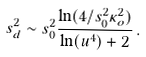<formula> <loc_0><loc_0><loc_500><loc_500>s _ { d } ^ { 2 } \sim s _ { 0 } ^ { 2 } \frac { \ln ( 4 / s _ { 0 } ^ { 2 } \kappa _ { o } ^ { 2 } ) } { \ln ( u ^ { 4 } ) + 2 } \, .</formula> 